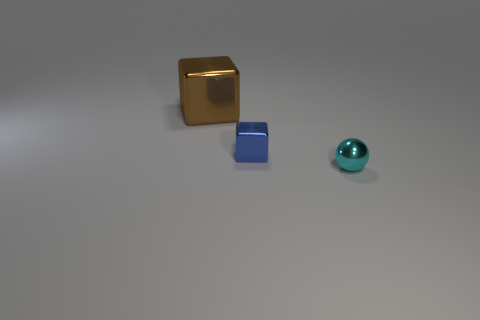How many other objects are there of the same size as the blue block?
Offer a very short reply. 1. There is a tiny object behind the cyan metallic thing; what is its material?
Ensure brevity in your answer.  Metal. Is the tiny blue metal thing the same shape as the large object?
Offer a very short reply. Yes. What number of other objects are there of the same shape as the small blue object?
Ensure brevity in your answer.  1. What color is the small thing behind the cyan metallic thing?
Your response must be concise. Blue. Do the brown thing and the cyan ball have the same size?
Ensure brevity in your answer.  No. What material is the thing that is in front of the small object that is behind the cyan object?
Offer a terse response. Metal. Is there anything else that is made of the same material as the large object?
Your response must be concise. Yes. Are there fewer big brown metal blocks right of the large brown metal cube than small blue metallic things?
Offer a terse response. Yes. There is a metal thing that is to the right of the tiny object left of the tiny cyan object; what color is it?
Your response must be concise. Cyan. 